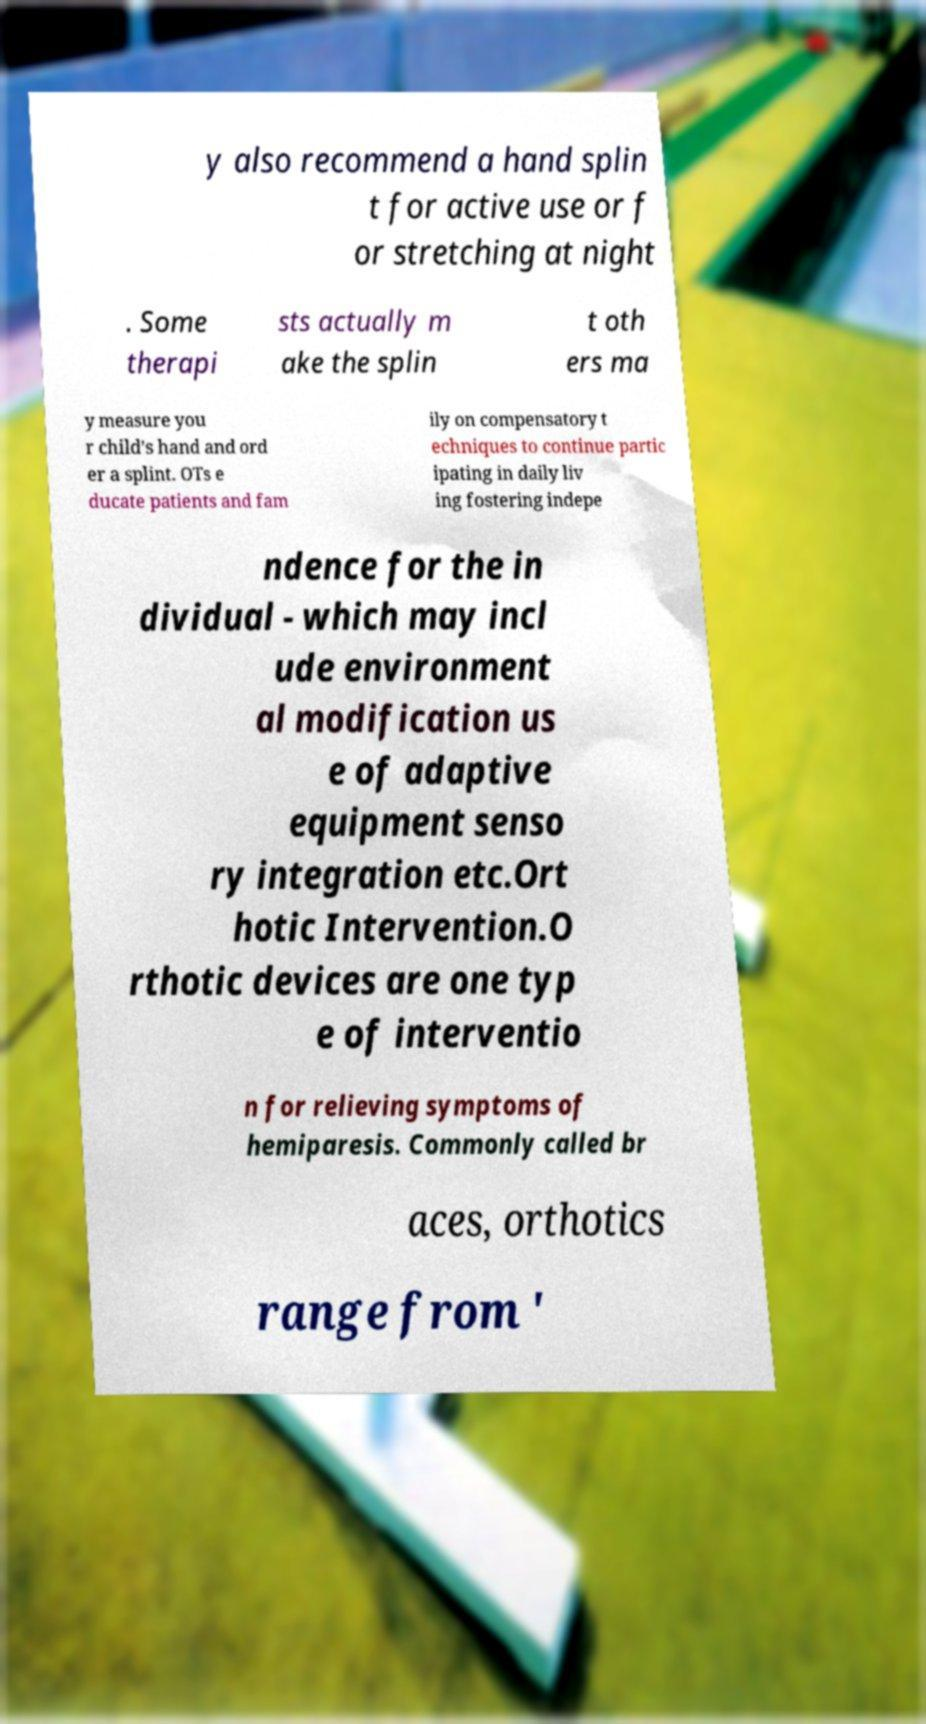Can you read and provide the text displayed in the image?This photo seems to have some interesting text. Can you extract and type it out for me? y also recommend a hand splin t for active use or f or stretching at night . Some therapi sts actually m ake the splin t oth ers ma y measure you r child’s hand and ord er a splint. OTs e ducate patients and fam ily on compensatory t echniques to continue partic ipating in daily liv ing fostering indepe ndence for the in dividual - which may incl ude environment al modification us e of adaptive equipment senso ry integration etc.Ort hotic Intervention.O rthotic devices are one typ e of interventio n for relieving symptoms of hemiparesis. Commonly called br aces, orthotics range from ' 